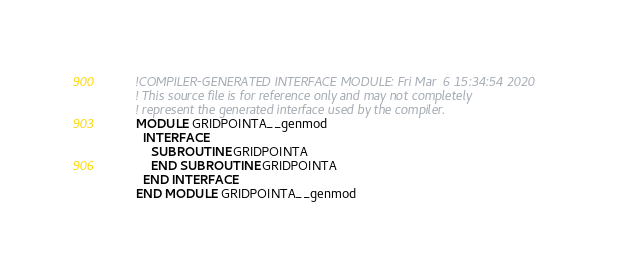Convert code to text. <code><loc_0><loc_0><loc_500><loc_500><_FORTRAN_>        !COMPILER-GENERATED INTERFACE MODULE: Fri Mar  6 15:34:54 2020
        ! This source file is for reference only and may not completely
        ! represent the generated interface used by the compiler.
        MODULE GRIDPOINTA__genmod
          INTERFACE 
            SUBROUTINE GRIDPOINTA
            END SUBROUTINE GRIDPOINTA
          END INTERFACE 
        END MODULE GRIDPOINTA__genmod
</code> 